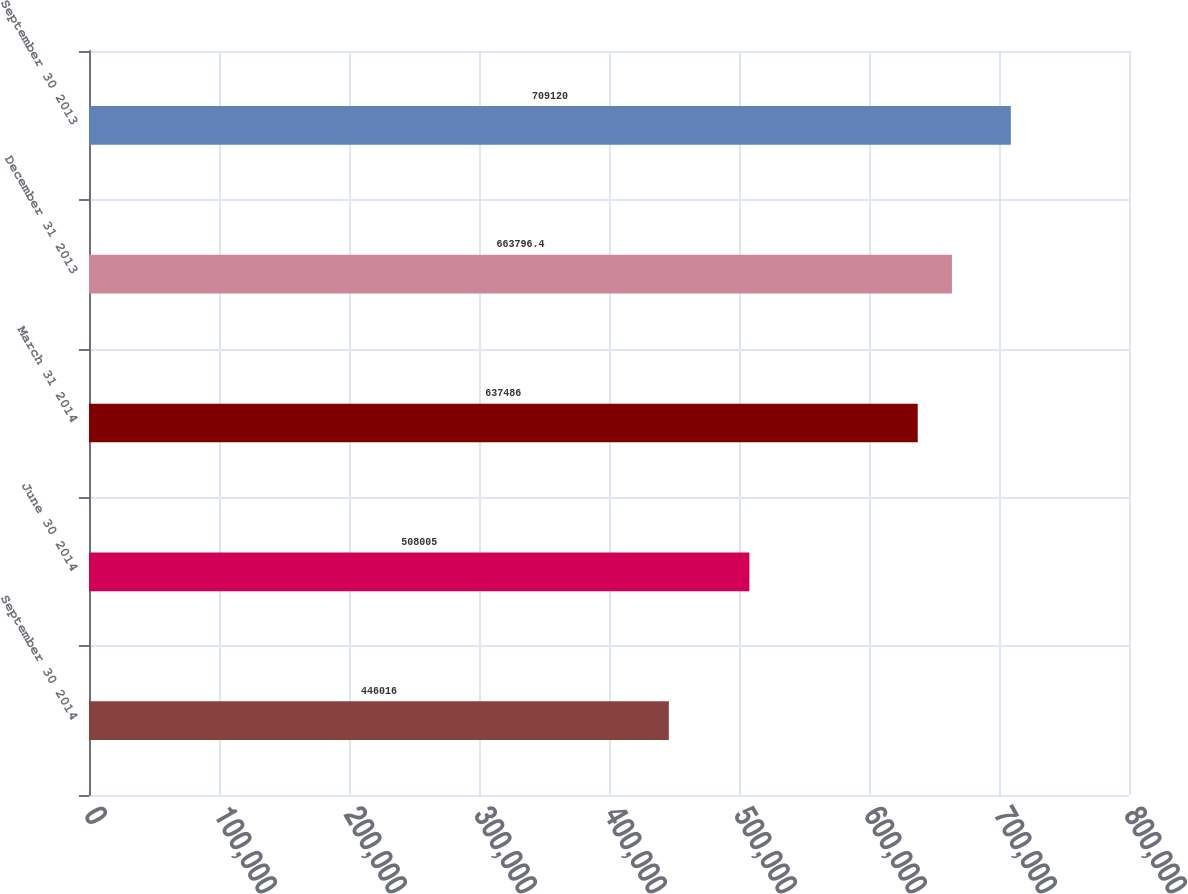Convert chart. <chart><loc_0><loc_0><loc_500><loc_500><bar_chart><fcel>September 30 2014<fcel>June 30 2014<fcel>March 31 2014<fcel>December 31 2013<fcel>September 30 2013<nl><fcel>446016<fcel>508005<fcel>637486<fcel>663796<fcel>709120<nl></chart> 